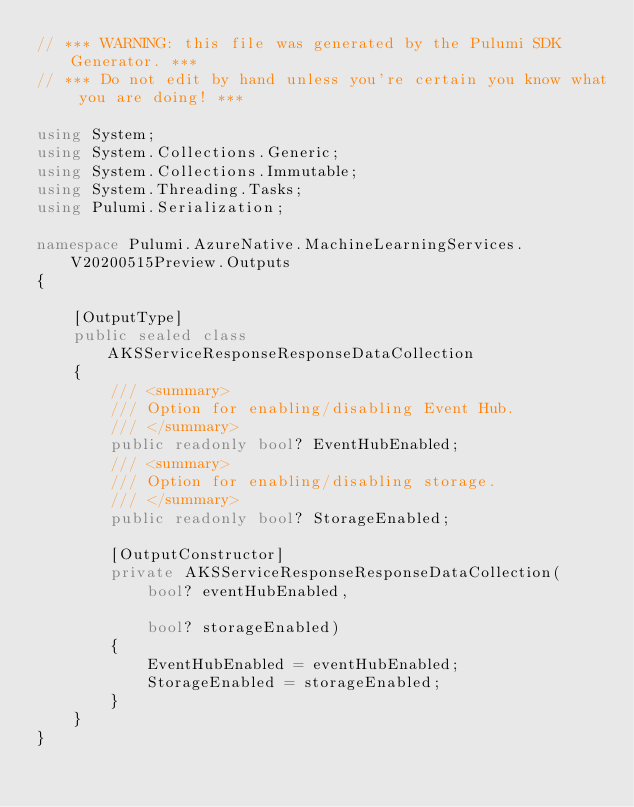<code> <loc_0><loc_0><loc_500><loc_500><_C#_>// *** WARNING: this file was generated by the Pulumi SDK Generator. ***
// *** Do not edit by hand unless you're certain you know what you are doing! ***

using System;
using System.Collections.Generic;
using System.Collections.Immutable;
using System.Threading.Tasks;
using Pulumi.Serialization;

namespace Pulumi.AzureNative.MachineLearningServices.V20200515Preview.Outputs
{

    [OutputType]
    public sealed class AKSServiceResponseResponseDataCollection
    {
        /// <summary>
        /// Option for enabling/disabling Event Hub.
        /// </summary>
        public readonly bool? EventHubEnabled;
        /// <summary>
        /// Option for enabling/disabling storage.
        /// </summary>
        public readonly bool? StorageEnabled;

        [OutputConstructor]
        private AKSServiceResponseResponseDataCollection(
            bool? eventHubEnabled,

            bool? storageEnabled)
        {
            EventHubEnabled = eventHubEnabled;
            StorageEnabled = storageEnabled;
        }
    }
}
</code> 